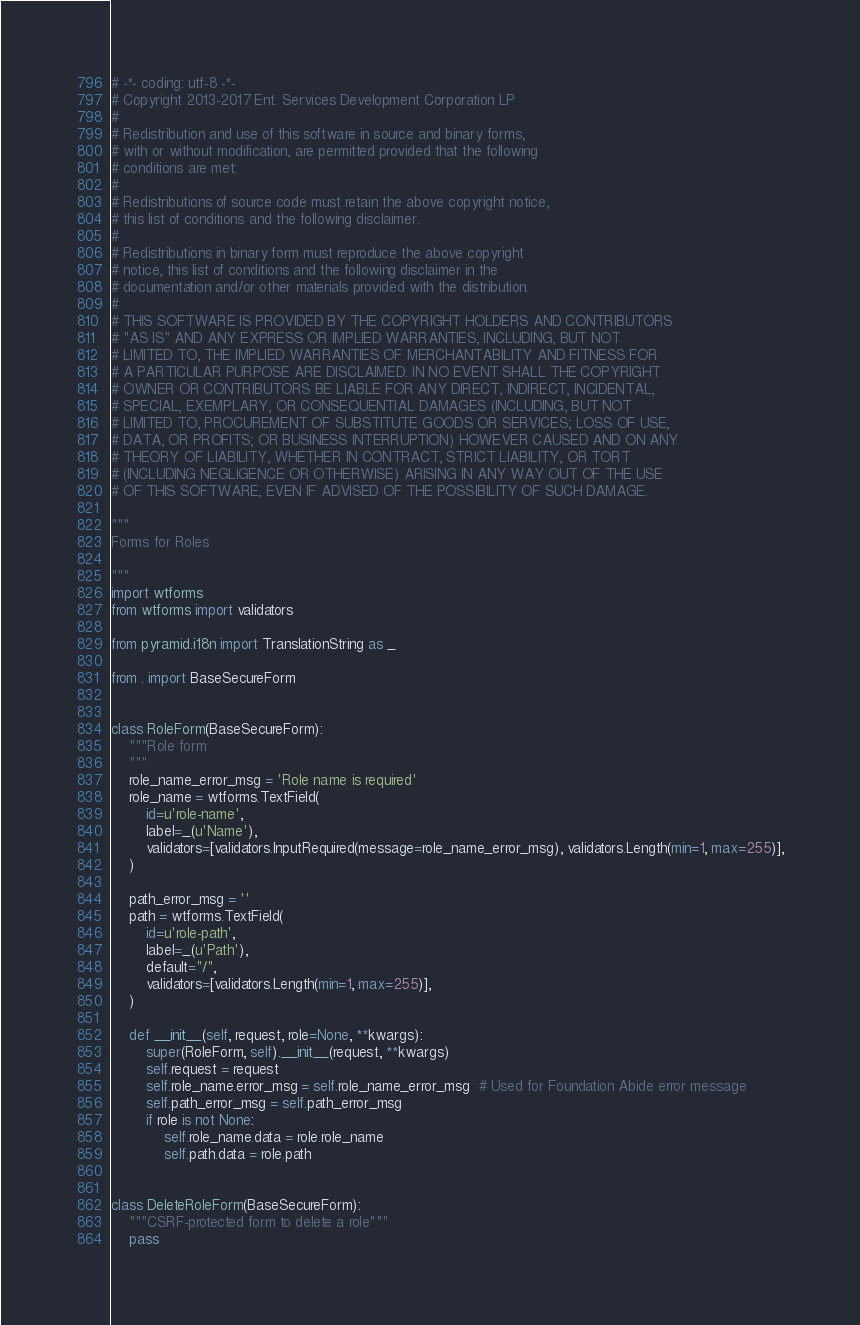Convert code to text. <code><loc_0><loc_0><loc_500><loc_500><_Python_># -*- coding: utf-8 -*-
# Copyright 2013-2017 Ent. Services Development Corporation LP
#
# Redistribution and use of this software in source and binary forms,
# with or without modification, are permitted provided that the following
# conditions are met:
#
# Redistributions of source code must retain the above copyright notice,
# this list of conditions and the following disclaimer.
#
# Redistributions in binary form must reproduce the above copyright
# notice, this list of conditions and the following disclaimer in the
# documentation and/or other materials provided with the distribution.
#
# THIS SOFTWARE IS PROVIDED BY THE COPYRIGHT HOLDERS AND CONTRIBUTORS
# "AS IS" AND ANY EXPRESS OR IMPLIED WARRANTIES, INCLUDING, BUT NOT
# LIMITED TO, THE IMPLIED WARRANTIES OF MERCHANTABILITY AND FITNESS FOR
# A PARTICULAR PURPOSE ARE DISCLAIMED. IN NO EVENT SHALL THE COPYRIGHT
# OWNER OR CONTRIBUTORS BE LIABLE FOR ANY DIRECT, INDIRECT, INCIDENTAL,
# SPECIAL, EXEMPLARY, OR CONSEQUENTIAL DAMAGES (INCLUDING, BUT NOT
# LIMITED TO, PROCUREMENT OF SUBSTITUTE GOODS OR SERVICES; LOSS OF USE,
# DATA, OR PROFITS; OR BUSINESS INTERRUPTION) HOWEVER CAUSED AND ON ANY
# THEORY OF LIABILITY, WHETHER IN CONTRACT, STRICT LIABILITY, OR TORT
# (INCLUDING NEGLIGENCE OR OTHERWISE) ARISING IN ANY WAY OUT OF THE USE
# OF THIS SOFTWARE, EVEN IF ADVISED OF THE POSSIBILITY OF SUCH DAMAGE.

"""
Forms for Roles

"""
import wtforms
from wtforms import validators

from pyramid.i18n import TranslationString as _

from . import BaseSecureForm


class RoleForm(BaseSecureForm):
    """Role form
    """
    role_name_error_msg = 'Role name is required'
    role_name = wtforms.TextField(
        id=u'role-name',
        label=_(u'Name'),
        validators=[validators.InputRequired(message=role_name_error_msg), validators.Length(min=1, max=255)],
    )

    path_error_msg = ''
    path = wtforms.TextField(
        id=u'role-path',
        label=_(u'Path'),
        default="/",
        validators=[validators.Length(min=1, max=255)],
    )

    def __init__(self, request, role=None, **kwargs):
        super(RoleForm, self).__init__(request, **kwargs)
        self.request = request
        self.role_name.error_msg = self.role_name_error_msg  # Used for Foundation Abide error message
        self.path_error_msg = self.path_error_msg
        if role is not None:
            self.role_name.data = role.role_name
            self.path.data = role.path


class DeleteRoleForm(BaseSecureForm):
    """CSRF-protected form to delete a role"""
    pass

</code> 